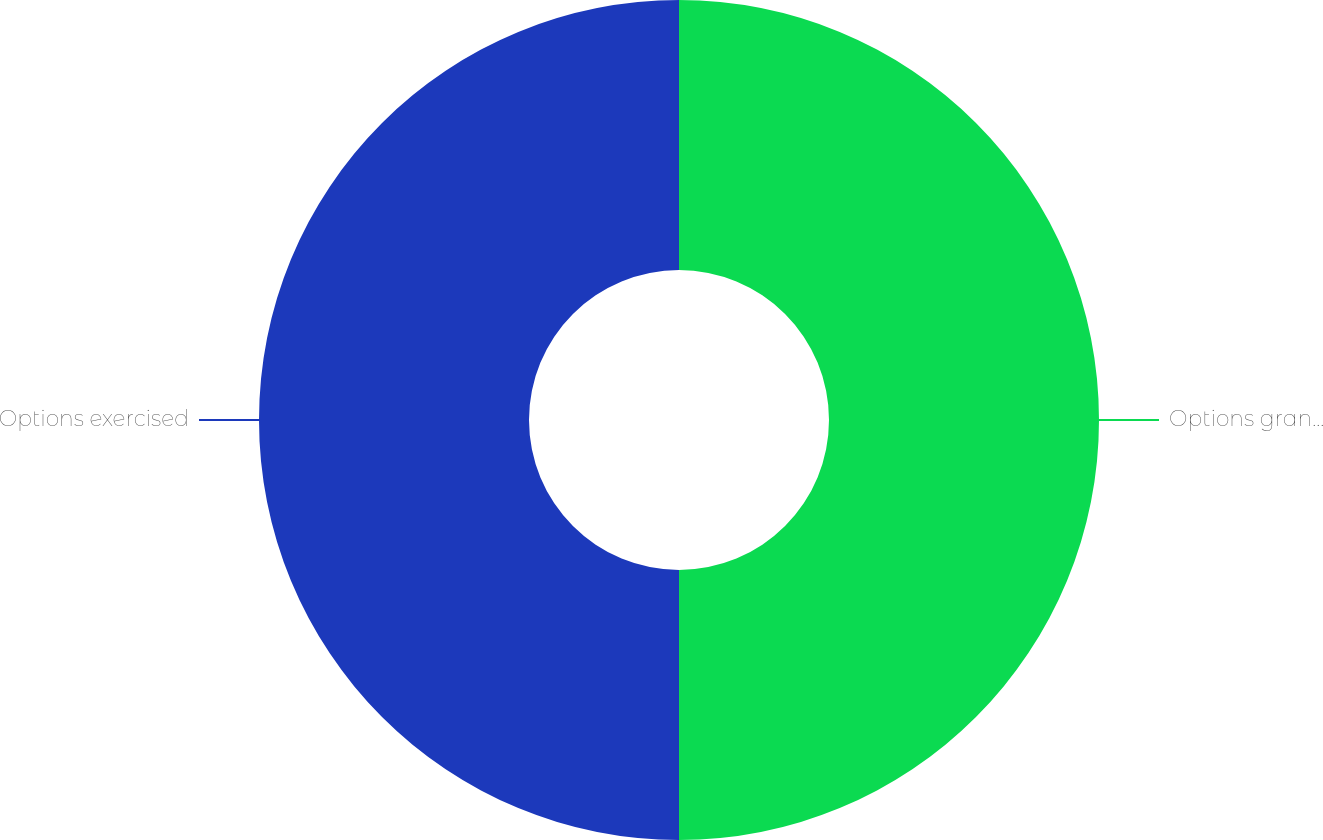Convert chart. <chart><loc_0><loc_0><loc_500><loc_500><pie_chart><fcel>Options granted<fcel>Options exercised<nl><fcel>50.0%<fcel>50.0%<nl></chart> 